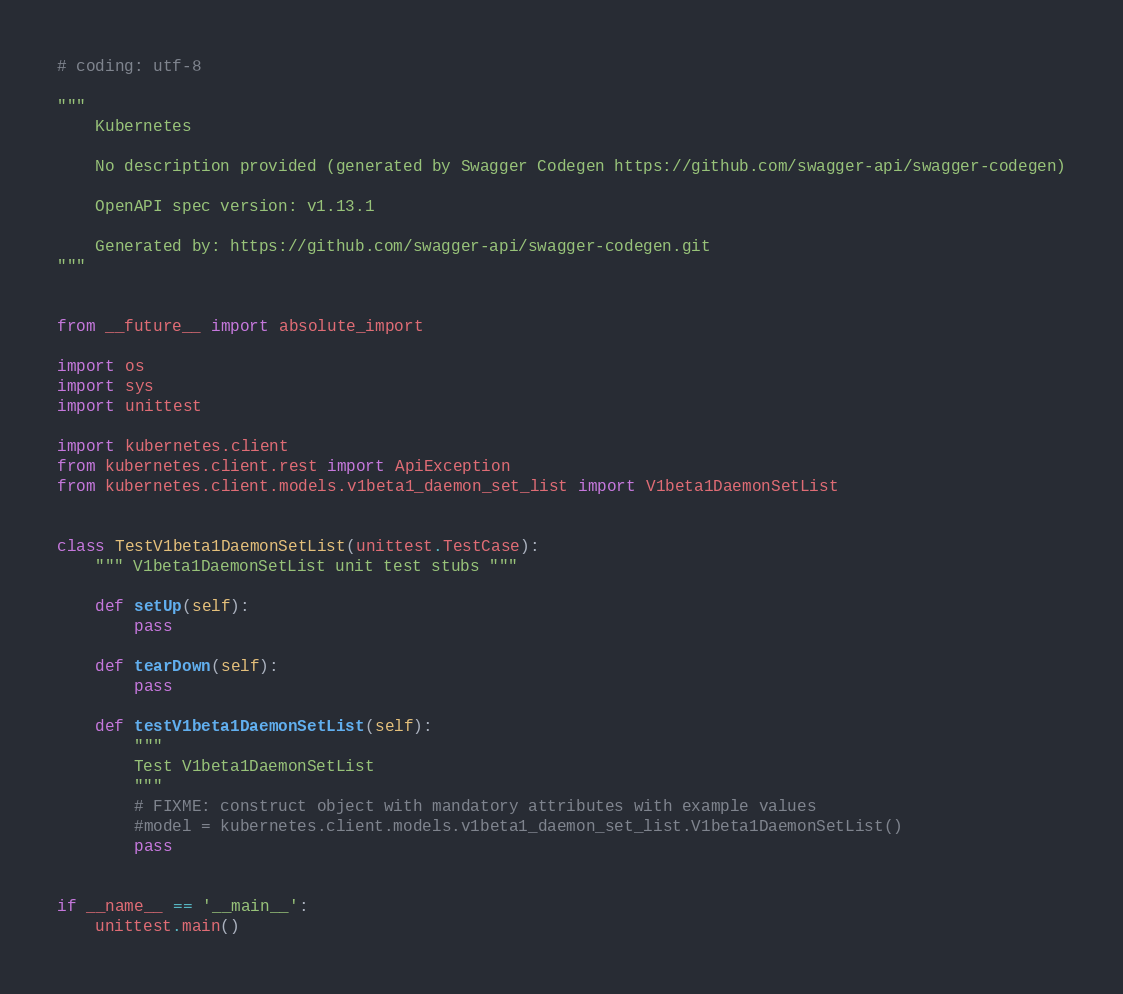<code> <loc_0><loc_0><loc_500><loc_500><_Python_># coding: utf-8

"""
    Kubernetes

    No description provided (generated by Swagger Codegen https://github.com/swagger-api/swagger-codegen)

    OpenAPI spec version: v1.13.1
    
    Generated by: https://github.com/swagger-api/swagger-codegen.git
"""


from __future__ import absolute_import

import os
import sys
import unittest

import kubernetes.client
from kubernetes.client.rest import ApiException
from kubernetes.client.models.v1beta1_daemon_set_list import V1beta1DaemonSetList


class TestV1beta1DaemonSetList(unittest.TestCase):
    """ V1beta1DaemonSetList unit test stubs """

    def setUp(self):
        pass

    def tearDown(self):
        pass

    def testV1beta1DaemonSetList(self):
        """
        Test V1beta1DaemonSetList
        """
        # FIXME: construct object with mandatory attributes with example values
        #model = kubernetes.client.models.v1beta1_daemon_set_list.V1beta1DaemonSetList()
        pass


if __name__ == '__main__':
    unittest.main()
</code> 